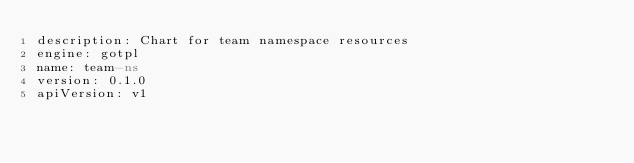Convert code to text. <code><loc_0><loc_0><loc_500><loc_500><_YAML_>description: Chart for team namespace resources
engine: gotpl
name: team-ns
version: 0.1.0
apiVersion: v1
</code> 